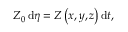<formula> <loc_0><loc_0><loc_500><loc_500>\begin{array} { r } { Z _ { 0 } \, d \eta = Z \left ( x , y , z \right ) d t , } \end{array}</formula> 